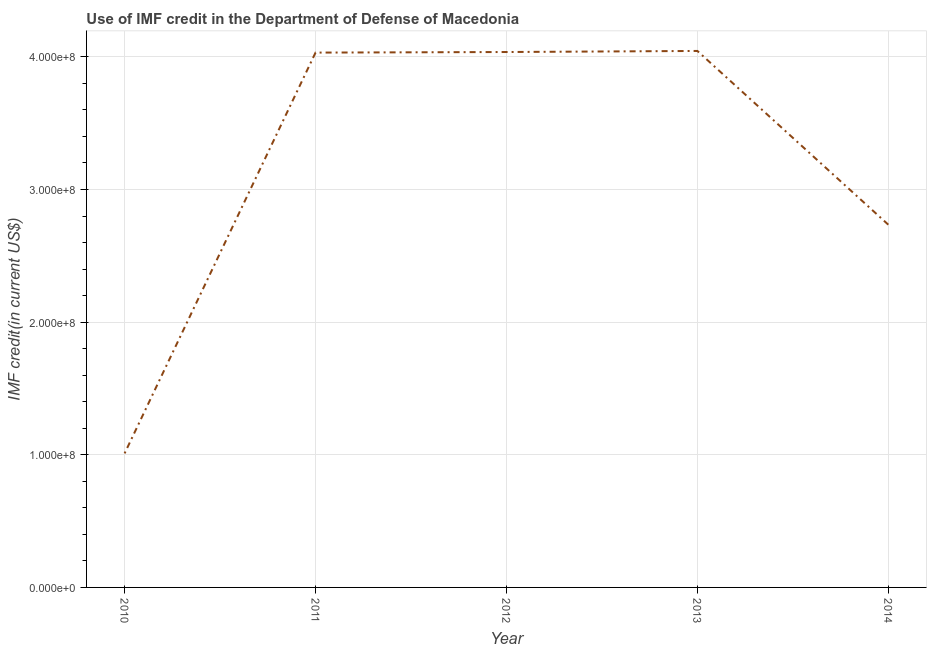What is the use of imf credit in dod in 2010?
Make the answer very short. 1.01e+08. Across all years, what is the maximum use of imf credit in dod?
Give a very brief answer. 4.04e+08. Across all years, what is the minimum use of imf credit in dod?
Offer a very short reply. 1.01e+08. In which year was the use of imf credit in dod maximum?
Your answer should be compact. 2013. In which year was the use of imf credit in dod minimum?
Offer a terse response. 2010. What is the sum of the use of imf credit in dod?
Ensure brevity in your answer.  1.59e+09. What is the difference between the use of imf credit in dod in 2010 and 2013?
Provide a succinct answer. -3.03e+08. What is the average use of imf credit in dod per year?
Your response must be concise. 3.17e+08. What is the median use of imf credit in dod?
Provide a succinct answer. 4.03e+08. In how many years, is the use of imf credit in dod greater than 100000000 US$?
Your answer should be compact. 5. What is the ratio of the use of imf credit in dod in 2011 to that in 2012?
Ensure brevity in your answer.  1. Is the use of imf credit in dod in 2010 less than that in 2014?
Ensure brevity in your answer.  Yes. Is the difference between the use of imf credit in dod in 2011 and 2013 greater than the difference between any two years?
Offer a very short reply. No. What is the difference between the highest and the second highest use of imf credit in dod?
Offer a very short reply. 8.09e+05. What is the difference between the highest and the lowest use of imf credit in dod?
Provide a short and direct response. 3.03e+08. Does the graph contain grids?
Keep it short and to the point. Yes. What is the title of the graph?
Offer a very short reply. Use of IMF credit in the Department of Defense of Macedonia. What is the label or title of the X-axis?
Keep it short and to the point. Year. What is the label or title of the Y-axis?
Provide a succinct answer. IMF credit(in current US$). What is the IMF credit(in current US$) of 2010?
Your answer should be compact. 1.01e+08. What is the IMF credit(in current US$) of 2011?
Keep it short and to the point. 4.03e+08. What is the IMF credit(in current US$) of 2012?
Your answer should be compact. 4.04e+08. What is the IMF credit(in current US$) in 2013?
Make the answer very short. 4.04e+08. What is the IMF credit(in current US$) of 2014?
Provide a succinct answer. 2.73e+08. What is the difference between the IMF credit(in current US$) in 2010 and 2011?
Make the answer very short. -3.02e+08. What is the difference between the IMF credit(in current US$) in 2010 and 2012?
Your answer should be very brief. -3.03e+08. What is the difference between the IMF credit(in current US$) in 2010 and 2013?
Your response must be concise. -3.03e+08. What is the difference between the IMF credit(in current US$) in 2010 and 2014?
Offer a terse response. -1.72e+08. What is the difference between the IMF credit(in current US$) in 2011 and 2012?
Ensure brevity in your answer.  -4.33e+05. What is the difference between the IMF credit(in current US$) in 2011 and 2013?
Your response must be concise. -1.24e+06. What is the difference between the IMF credit(in current US$) in 2011 and 2014?
Ensure brevity in your answer.  1.30e+08. What is the difference between the IMF credit(in current US$) in 2012 and 2013?
Your answer should be compact. -8.09e+05. What is the difference between the IMF credit(in current US$) in 2012 and 2014?
Provide a succinct answer. 1.30e+08. What is the difference between the IMF credit(in current US$) in 2013 and 2014?
Offer a terse response. 1.31e+08. What is the ratio of the IMF credit(in current US$) in 2010 to that in 2011?
Provide a succinct answer. 0.25. What is the ratio of the IMF credit(in current US$) in 2010 to that in 2013?
Provide a succinct answer. 0.25. What is the ratio of the IMF credit(in current US$) in 2010 to that in 2014?
Provide a short and direct response. 0.37. What is the ratio of the IMF credit(in current US$) in 2011 to that in 2012?
Provide a succinct answer. 1. What is the ratio of the IMF credit(in current US$) in 2011 to that in 2013?
Give a very brief answer. 1. What is the ratio of the IMF credit(in current US$) in 2011 to that in 2014?
Your response must be concise. 1.47. What is the ratio of the IMF credit(in current US$) in 2012 to that in 2013?
Your answer should be very brief. 1. What is the ratio of the IMF credit(in current US$) in 2012 to that in 2014?
Your answer should be very brief. 1.48. What is the ratio of the IMF credit(in current US$) in 2013 to that in 2014?
Your answer should be compact. 1.48. 